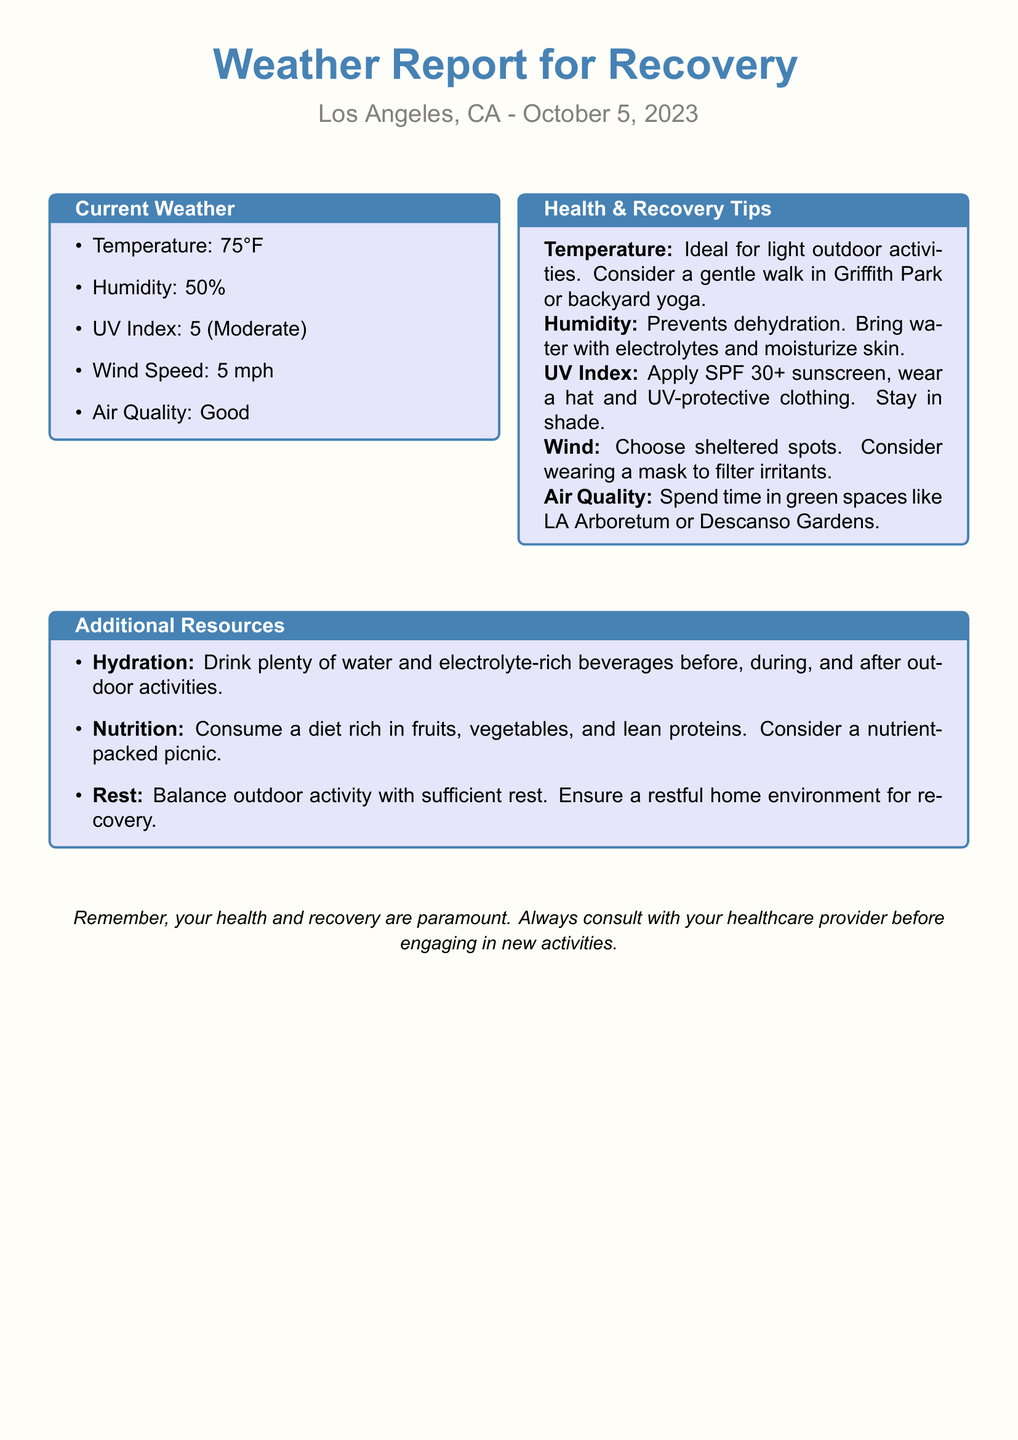What is the temperature? The document states the current temperature as 75°F.
Answer: 75°F What is the humidity level? The current humidity level is indicated as 50%.
Answer: 50% What is the UV Index rating? The UV Index is reported as 5, which is categorized as Moderate.
Answer: 5 What outdoor activity is recommended for recovery? The document suggests gentle walking in Griffith Park or backyard yoga for light outdoor activities.
Answer: Gentle walk What type of sunscreen should be applied? The report recommends applying SPF 30+ sunscreen.
Answer: SPF 30+ What is the suggestion for hydration? The document emphasizes drinking plenty of water and electrolyte-rich beverages.
Answer: Plenty of water Why is the humidity considered beneficial? Humidity helps prevent dehydration according to the health tips provided.
Answer: Prevents dehydration What type of environment is recommended for outdoor activities? The document advises spending time in green spaces like LA Arboretum or Descanso Gardens.
Answer: Green spaces Which protective clothing is suggested? Wearing a hat and UV-protective clothing is recommended to protect against the sun.
Answer: UV-protective clothing What should you do if the wind is strong? The report suggests choosing sheltered spots and potentially wearing a mask.
Answer: Choose sheltered spots 